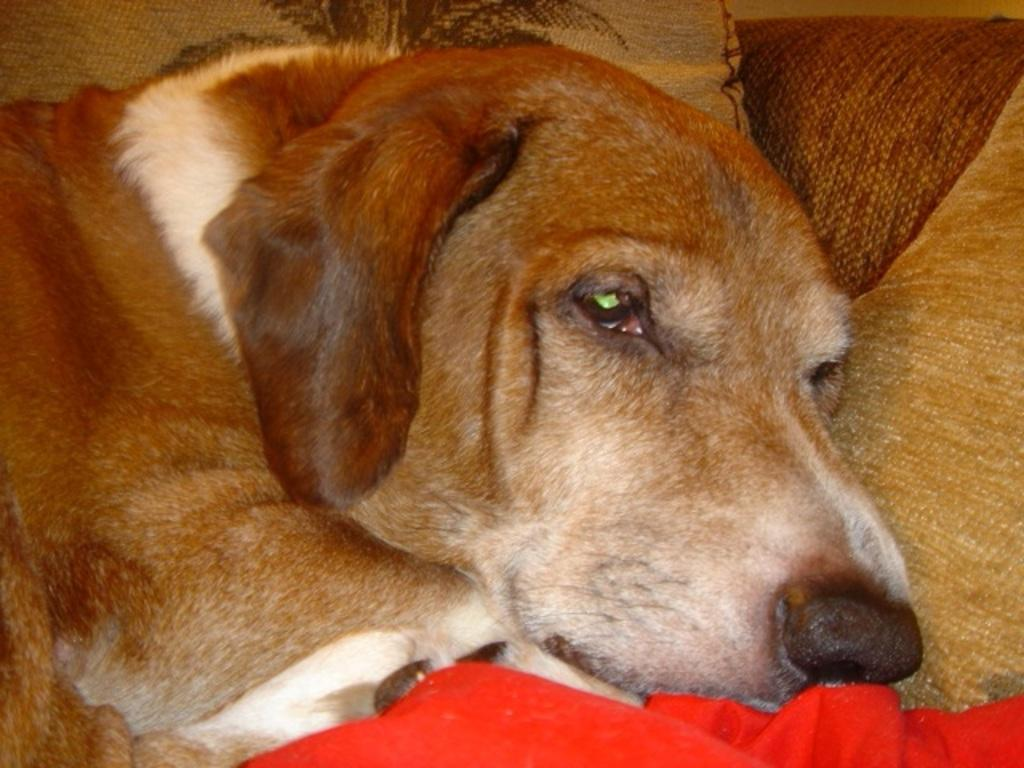What type of animal is present in the image? There is a dog in the image. Can you describe the red-colored object at the bottom of the image? Unfortunately, the facts provided do not give any information about the red-colored object at the bottom of the image. What direction is the bread being sliced in the image? There is no bread present in the image, so it is not possible to determine the direction in which it would be sliced. 